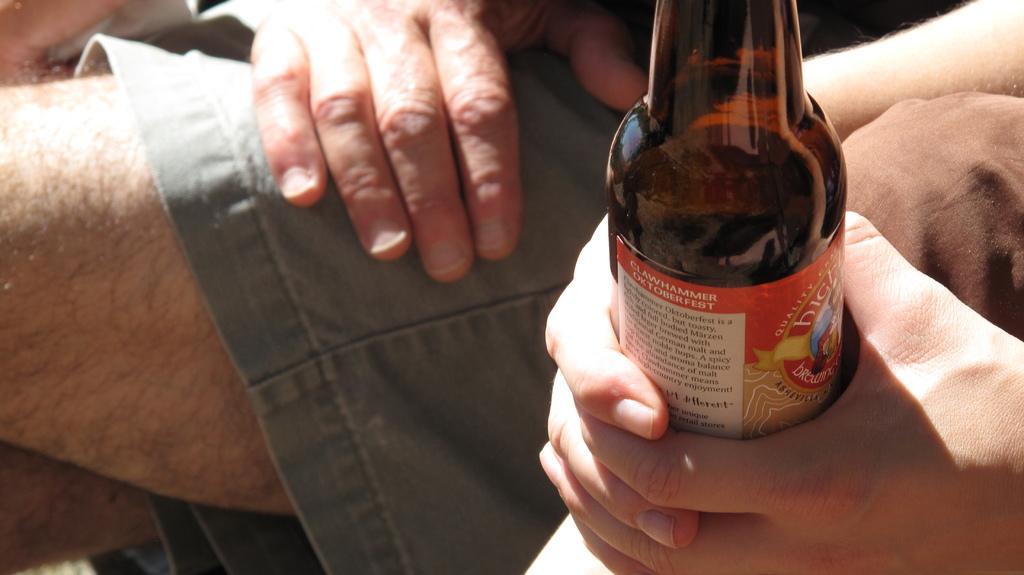How would you summarize this image in a sentence or two? In this picture there is a beer bottle and a person's hand 